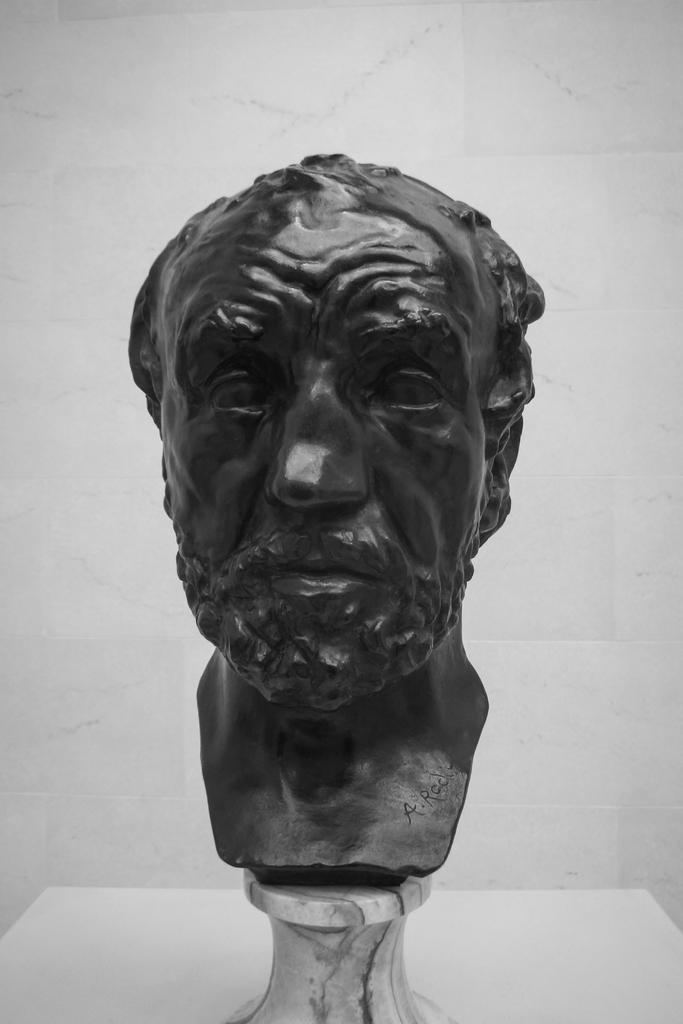What is the main subject of the image? There is a statue of a person in the image. What color is the statue's face? The statue's face is in black color. What color is the background of the image? The background of the image is in white color. Can you see any icicles hanging from the statue's face in the image? There are no icicles present in the image; the statue's face is in black color. What type of badge is the statue wearing in the image? The statue is not wearing a badge in the image; it is a statue and does not have any clothing or accessories. 